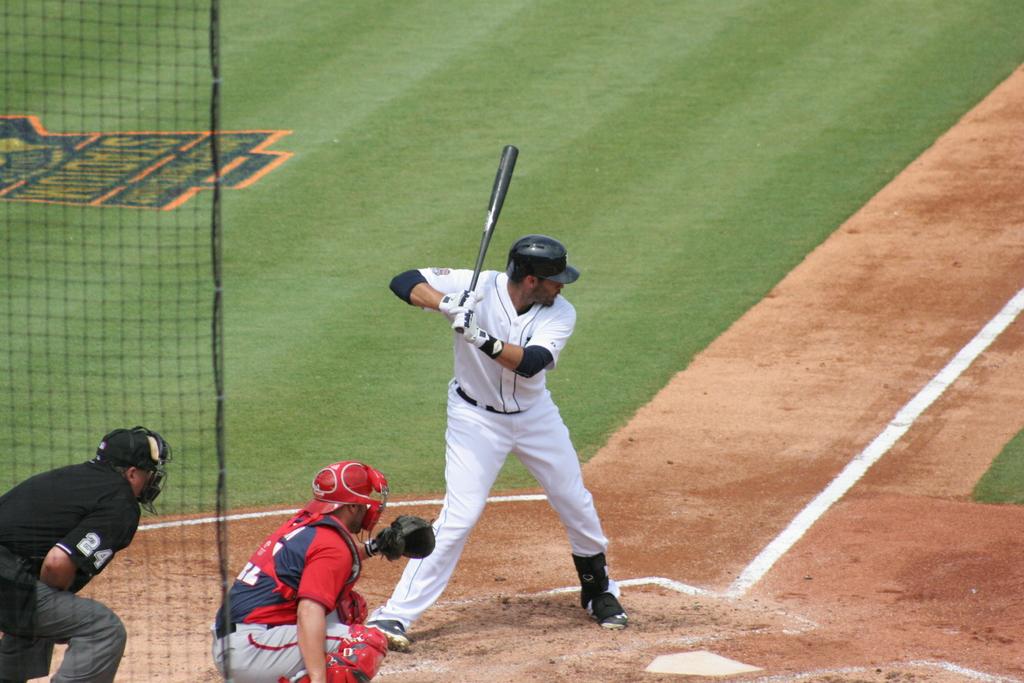What is the umpires jersey number?
Offer a very short reply. 24. 